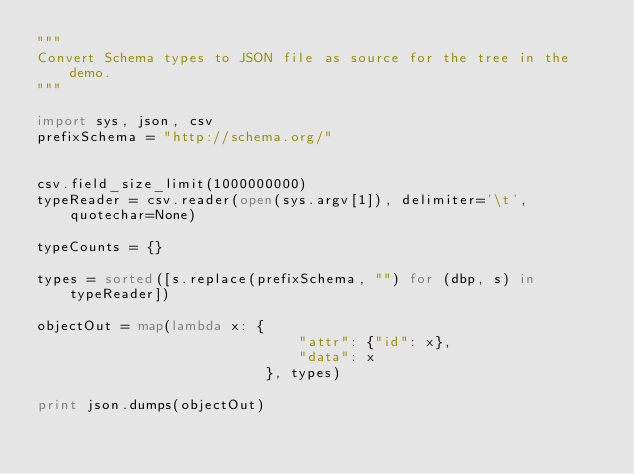<code> <loc_0><loc_0><loc_500><loc_500><_Python_>"""
Convert Schema types to JSON file as source for the tree in the demo.
"""

import sys, json, csv
prefixSchema = "http://schema.org/"


csv.field_size_limit(1000000000)
typeReader = csv.reader(open(sys.argv[1]), delimiter='\t', quotechar=None)

typeCounts = {}

types = sorted([s.replace(prefixSchema, "") for (dbp, s) in typeReader])

objectOut = map(lambda x: {
                               "attr": {"id": x},
                               "data": x
                           }, types)

print json.dumps(objectOut)


</code> 